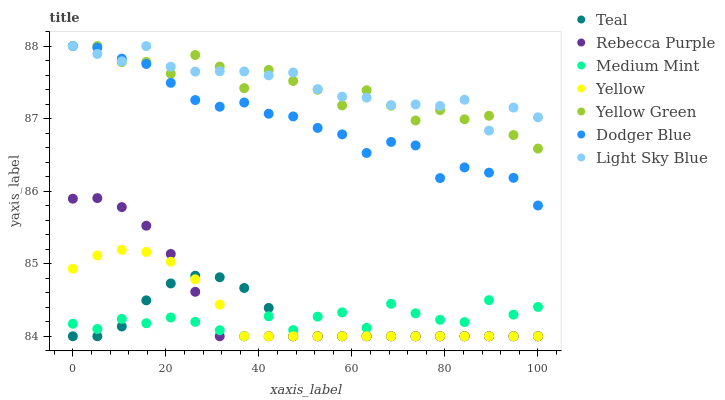Does Teal have the minimum area under the curve?
Answer yes or no. Yes. Does Light Sky Blue have the maximum area under the curve?
Answer yes or no. Yes. Does Yellow Green have the minimum area under the curve?
Answer yes or no. No. Does Yellow Green have the maximum area under the curve?
Answer yes or no. No. Is Yellow the smoothest?
Answer yes or no. Yes. Is Yellow Green the roughest?
Answer yes or no. Yes. Is Yellow Green the smoothest?
Answer yes or no. No. Is Yellow the roughest?
Answer yes or no. No. Does Medium Mint have the lowest value?
Answer yes or no. Yes. Does Yellow Green have the lowest value?
Answer yes or no. No. Does Dodger Blue have the highest value?
Answer yes or no. Yes. Does Yellow have the highest value?
Answer yes or no. No. Is Medium Mint less than Yellow Green?
Answer yes or no. Yes. Is Dodger Blue greater than Rebecca Purple?
Answer yes or no. Yes. Does Light Sky Blue intersect Dodger Blue?
Answer yes or no. Yes. Is Light Sky Blue less than Dodger Blue?
Answer yes or no. No. Is Light Sky Blue greater than Dodger Blue?
Answer yes or no. No. Does Medium Mint intersect Yellow Green?
Answer yes or no. No. 